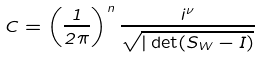<formula> <loc_0><loc_0><loc_500><loc_500>C = \left ( \frac { 1 } { 2 \pi } \right ) ^ { n } \frac { i ^ { \nu } } { \sqrt { | \det ( S _ { W } - I ) } }</formula> 